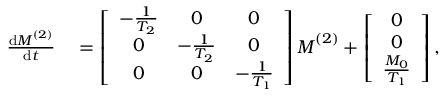<formula> <loc_0><loc_0><loc_500><loc_500>\begin{array} { r l } { \frac { d M ^ { ( 2 ) } } { d t } } & = \left [ \begin{array} { c c c } { - \frac { 1 } { T _ { 2 } } } & { 0 } & { 0 } \\ { 0 } & { - \frac { 1 } { T _ { 2 } } } & { 0 } \\ { 0 } & { 0 } & { - \frac { 1 } { T _ { 1 } } } \end{array} \right ] M ^ { ( 2 ) } + \left [ \begin{array} { c } { 0 } \\ { 0 } \\ { \frac { M _ { 0 } } { T _ { 1 } } } \end{array} \right ] , } \end{array}</formula> 